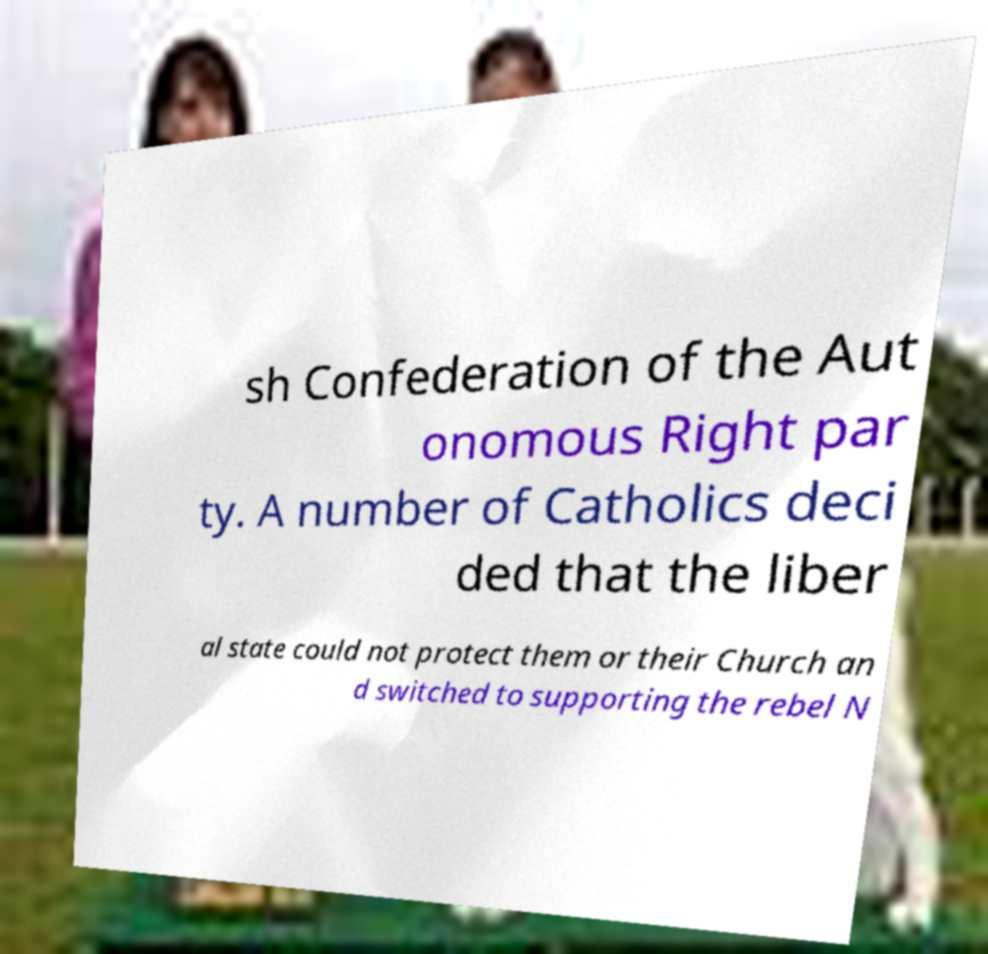For documentation purposes, I need the text within this image transcribed. Could you provide that? sh Confederation of the Aut onomous Right par ty. A number of Catholics deci ded that the liber al state could not protect them or their Church an d switched to supporting the rebel N 